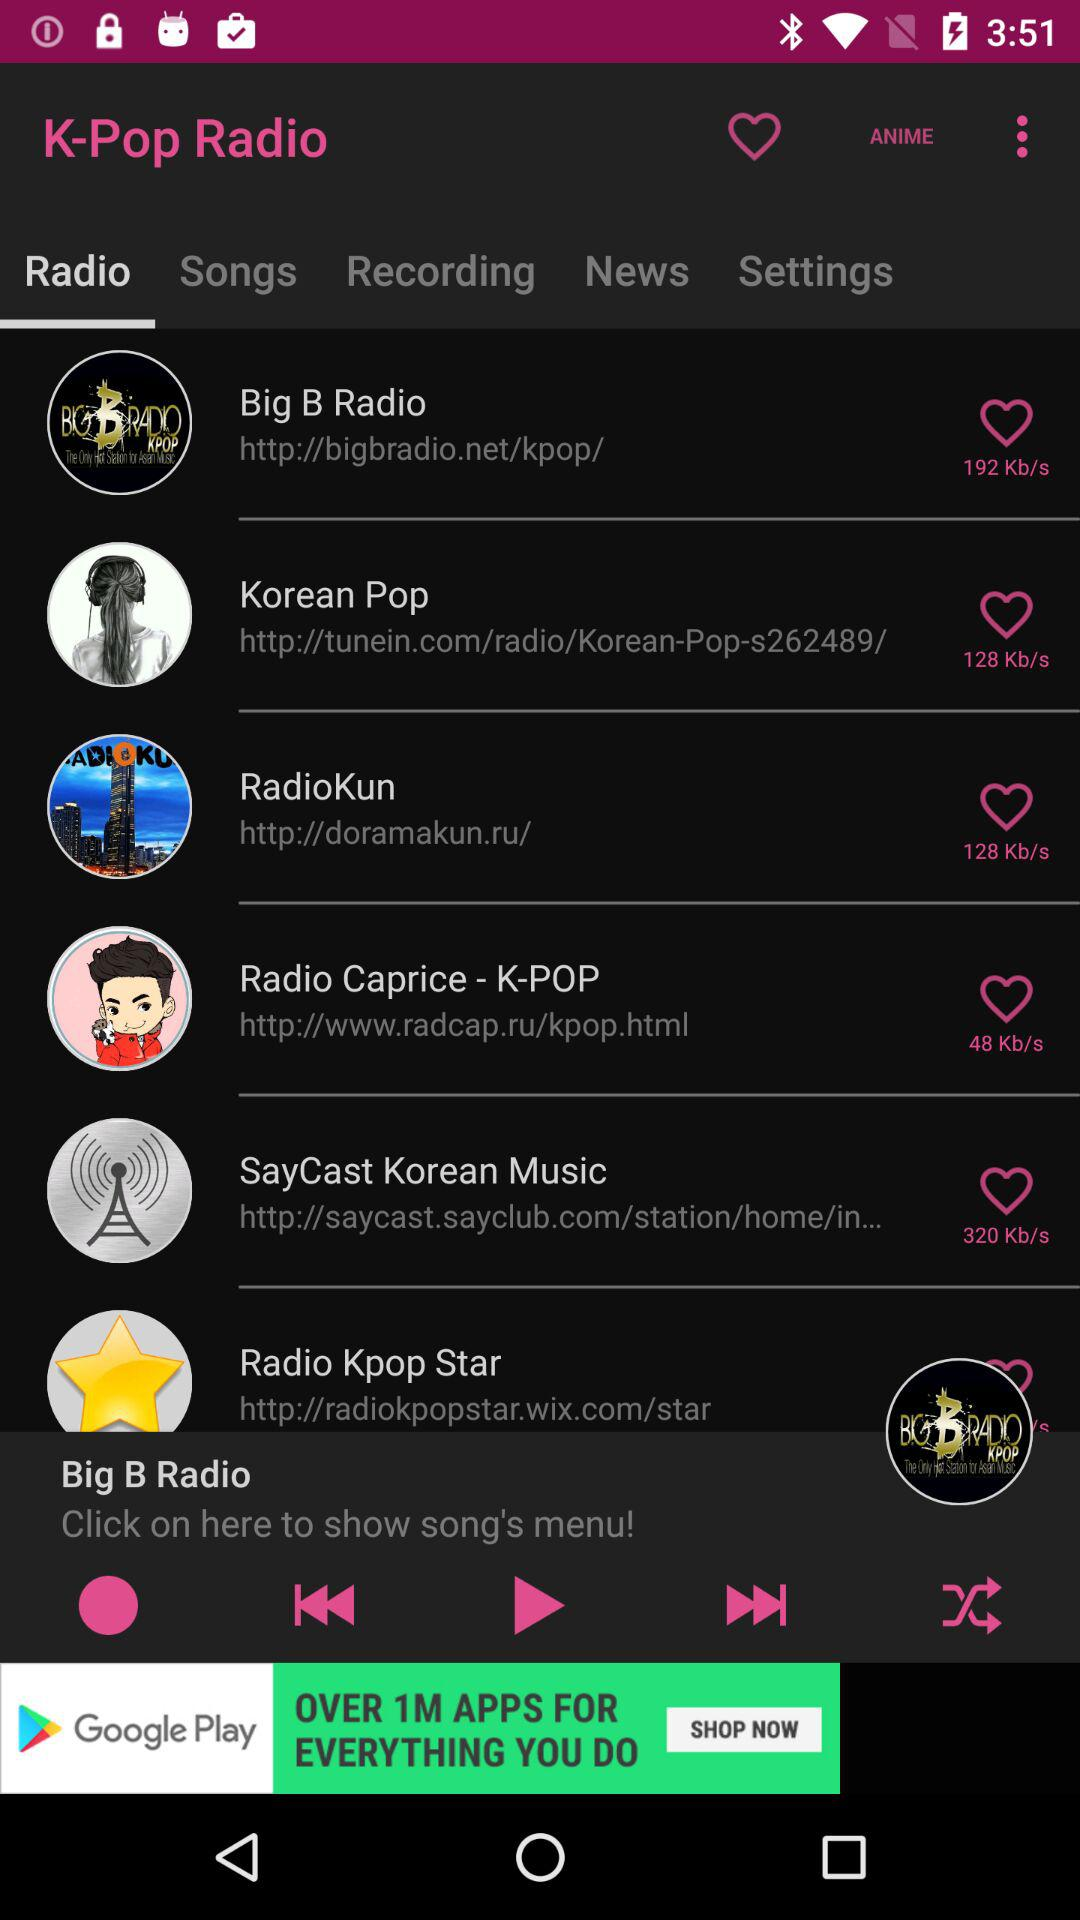What is the speed of the "Korean Pop"? The speed of the "Korean Pop" is 128 kb/s. 